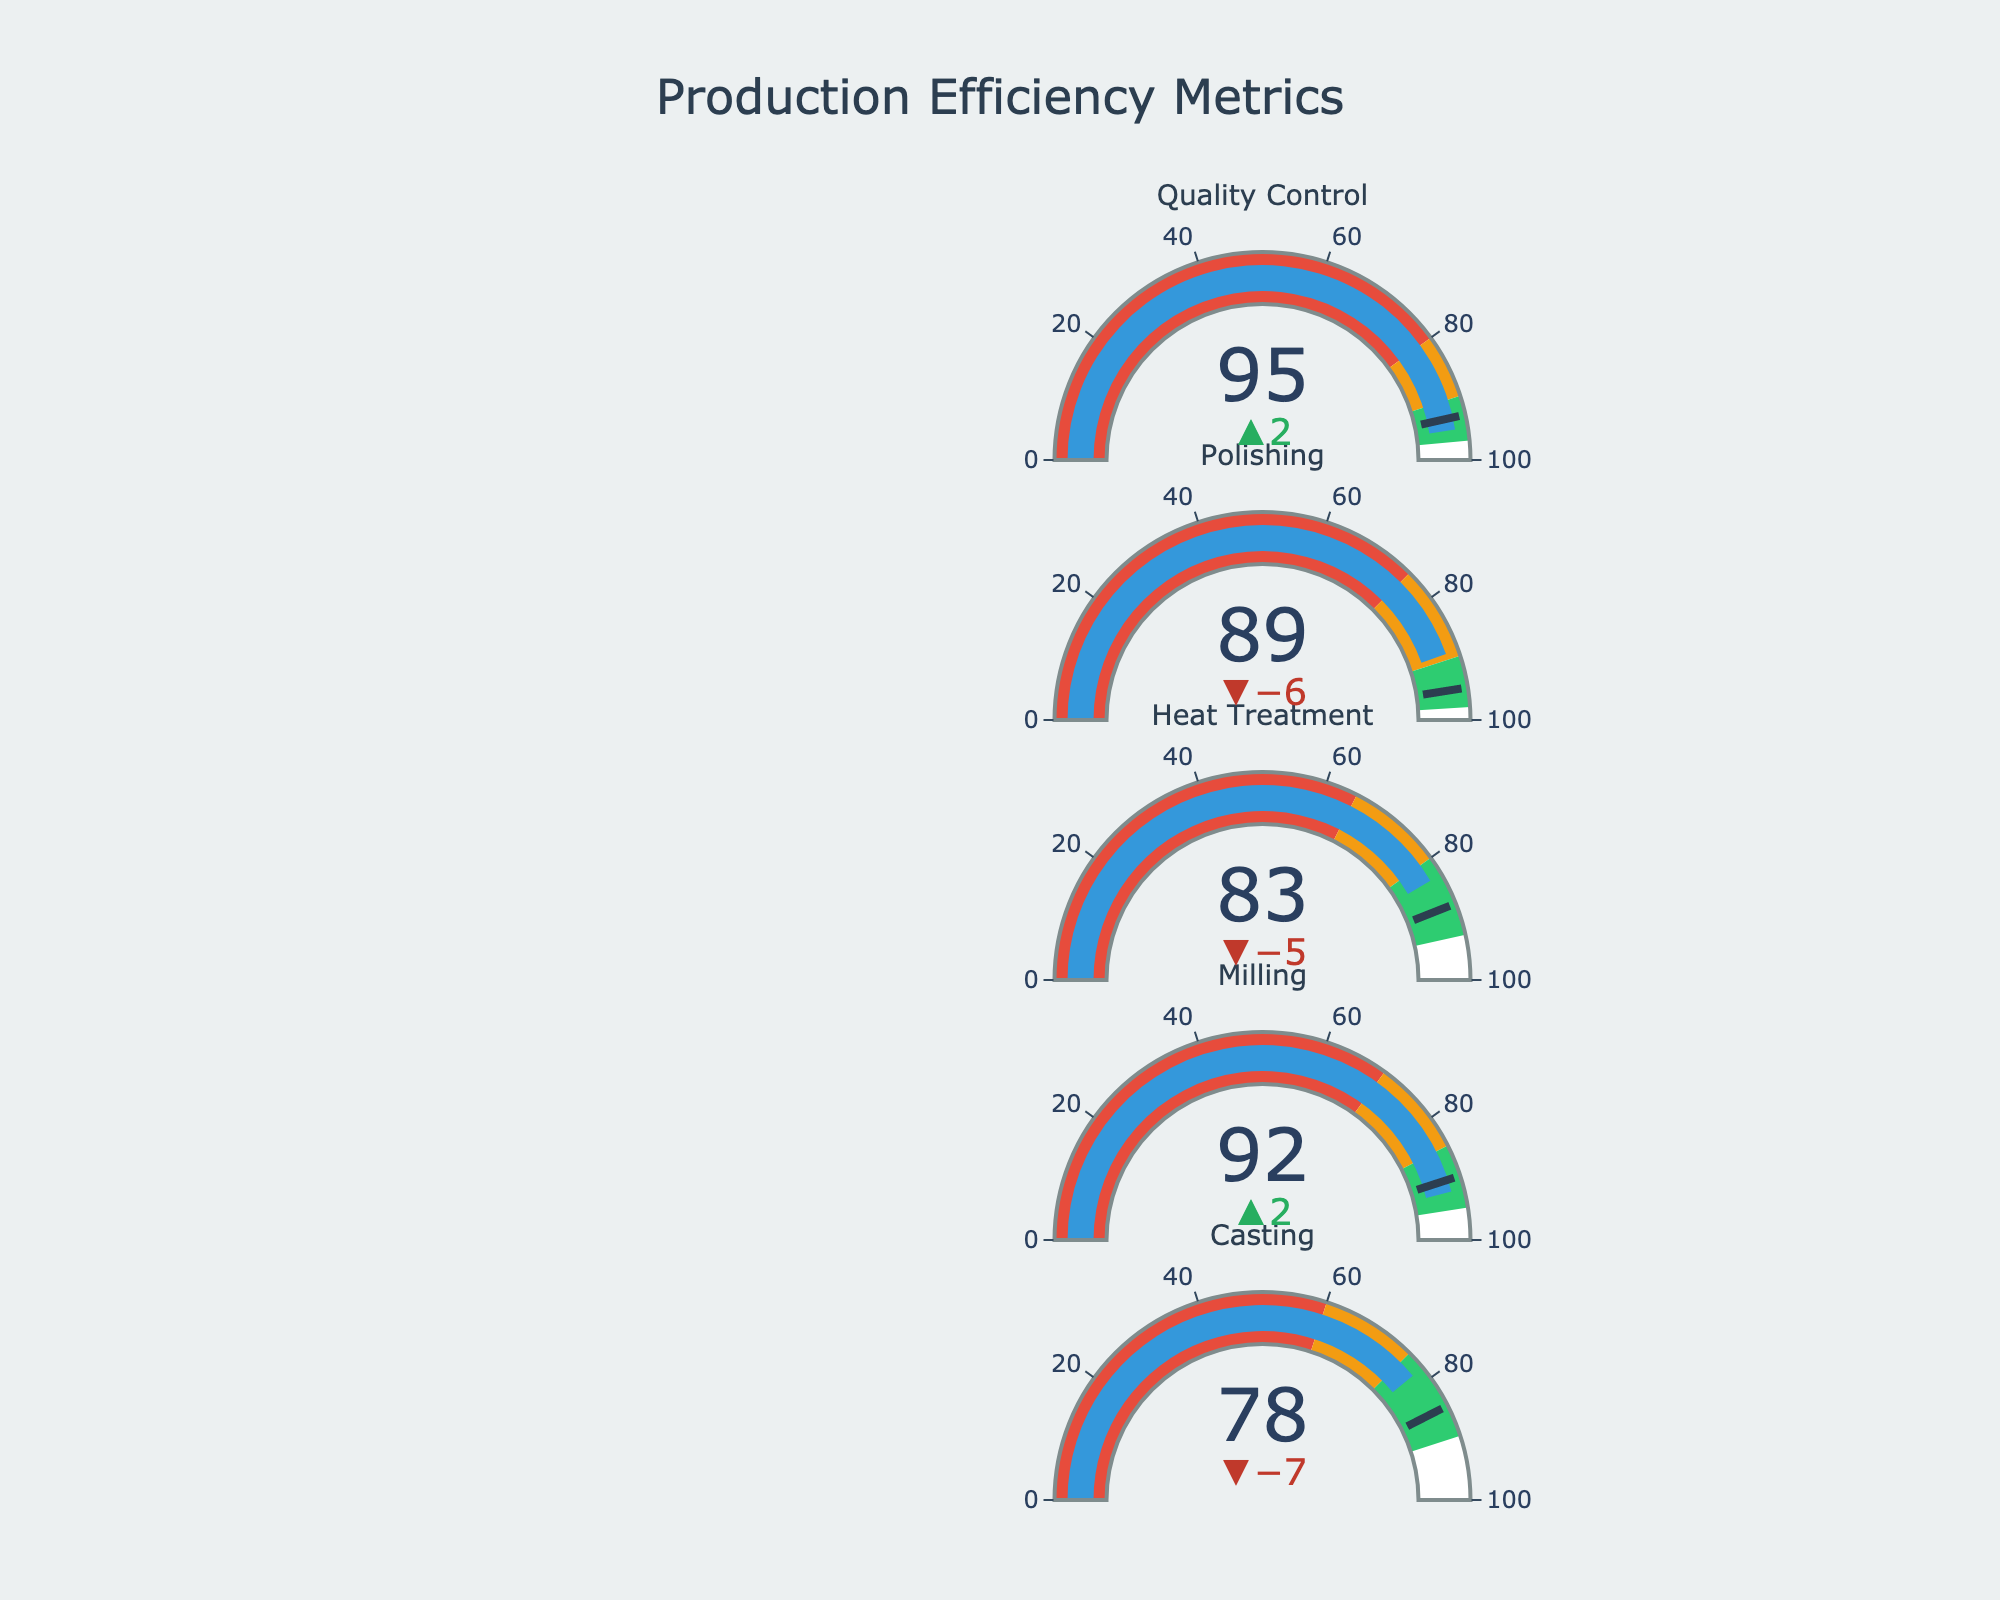What's the process with the highest actual value? First, identify the actual values for all processes: Casting (78), Milling (92), Heat Treatment (83), Polishing (89), and Quality Control (95). Quality Control has the highest value of 95.
Answer: Quality Control What is the target threshold for the Polishing process? Look at the target value listed specifically for Polishing, which is 95.
Answer: 95 Which process has the largest positive delta from its target value? Check the difference (delta) between actual and target for each process. The deltas are: Casting (-7), Milling (2), Heat Treatment (-5), Polishing (-6), and Quality Control (2). Milling and Quality Control have the largest positive delta of 2 each.
Answer: Milling, Quality Control What are the ranges for the "Satisfactory" category for the Heat Treatment process? Refer to the "Poor" and "Good" thresholds for Heat Treatment. The "Satisfactory" range is from the Poor threshold (65) to the Good threshold (93), meaning (80-93).
Answer: 80-93 Which processes' actual values fall within their "Good" category? Compare actual values to the ranges defined as "Good": Casting (90+), Milling (85+), Heat Treatment (80+), Polishing (90+), and Quality Control (90+). The ones that qualify are Milling (92), Quality Control (95).
Answer: Milling, Quality Control How many processes have an actual value below their target? Compare actual values with the target values for each process: Casting (78 < 85), Milling (92 > 90), Heat Treatment (83 < 88), Polishing (89 < 95), Quality Control (95 > 93). Three processes fall below their targets: Casting, Heat Treatment, and Polishing.
Answer: 3 What's the difference between the actual value and the "Poor" threshold for Milling? Identify the actual value (92) and the Poor threshold (70) for Milling, then calculate the difference: 92 - 70 = 22.
Answer: 22 Which process shows the smallest negative delta from its target? Check the negative differences (deltas) for each process: Casting (-7), Heat Treatment (-5), Polishing (-6). The smallest negative delta is for Heat Treatment with -5.
Answer: Heat Treatment What's the average actual value for all processes? Sum the actual values for all processes: 78 + 92 + 83 + 89 + 95 = 437. Divide by the number of processes (5), resulting in an average of 437/5 = 87.4.
Answer: 87.4 What percentage of processes meet or exceed their target value? Count the processes meeting or exceeding their targets: Milling (92 >= 90) and Quality Control (95 >= 93). There are 2 out of 5 processes, equating to (2/5)*100 = 40%.
Answer: 40% 